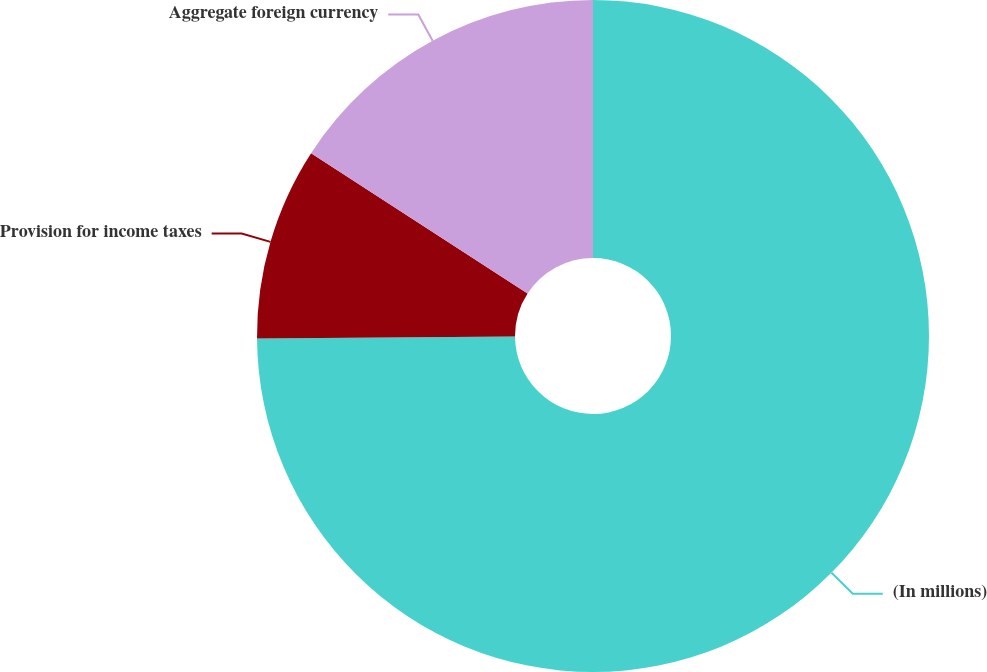Convert chart. <chart><loc_0><loc_0><loc_500><loc_500><pie_chart><fcel>(In millions)<fcel>Provision for income taxes<fcel>Aggregate foreign currency<nl><fcel>74.87%<fcel>9.28%<fcel>15.84%<nl></chart> 